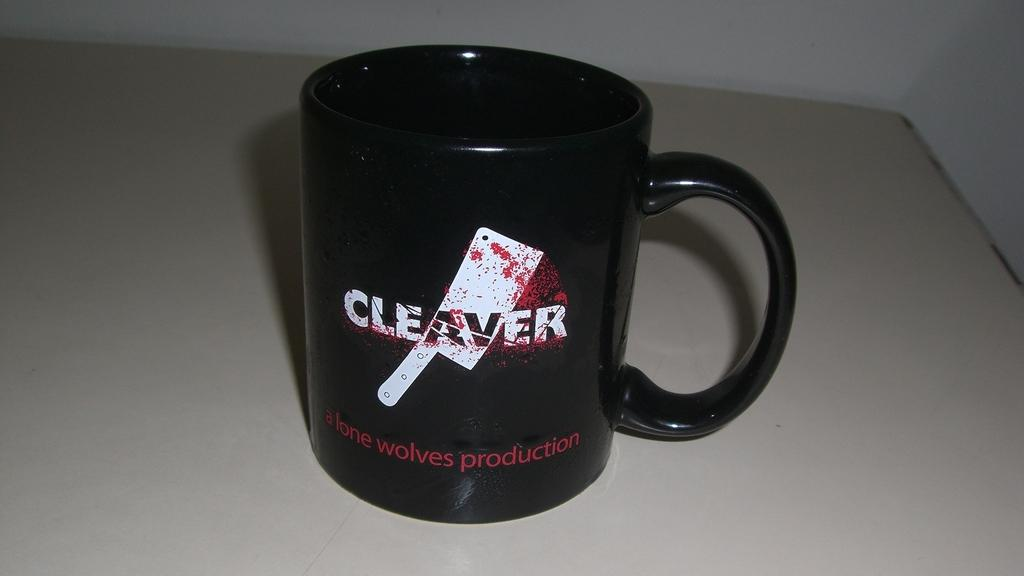<image>
Summarize the visual content of the image. A coffee mug with "A Lone Wolves Production in print on the mug. 